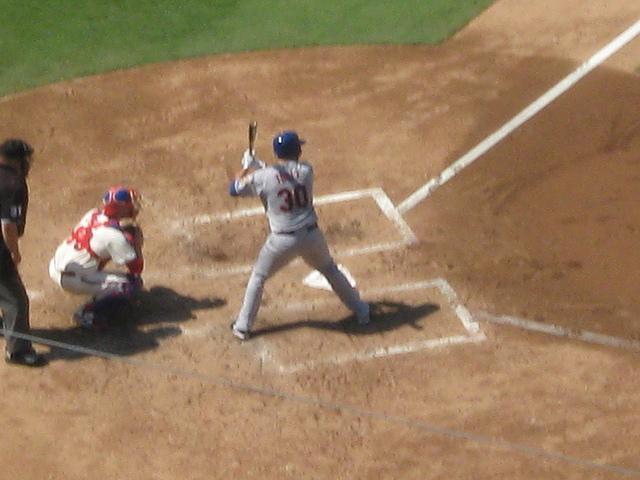How many people are there?
Give a very brief answer. 3. 